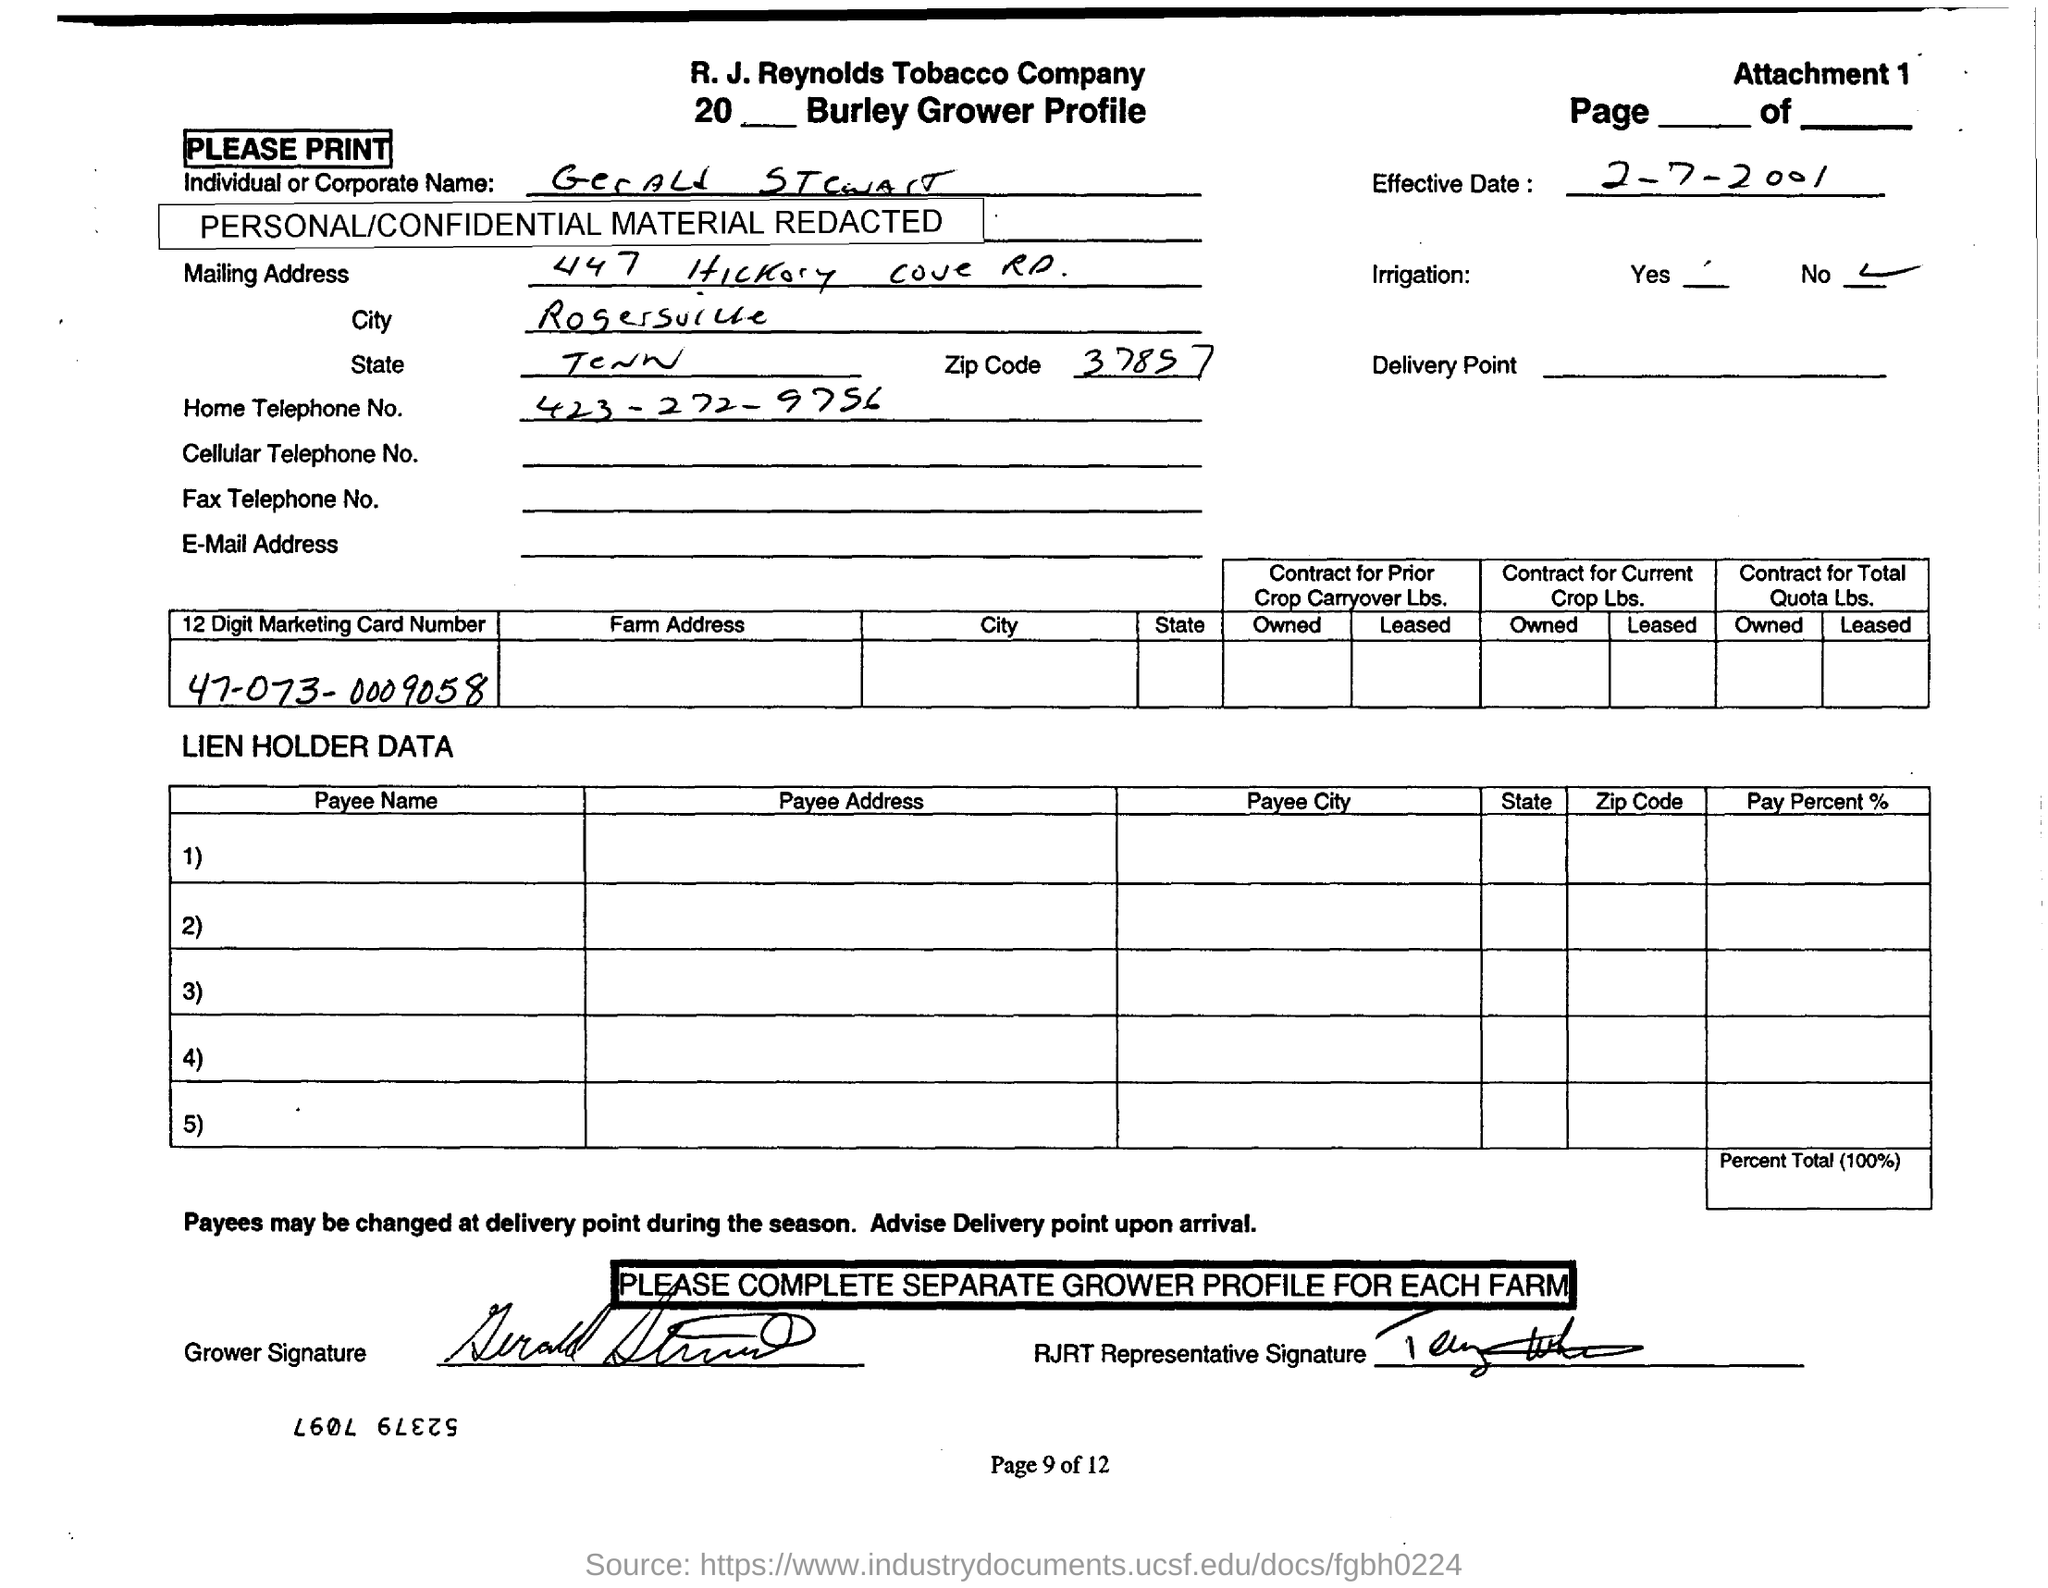Point out several critical features in this image. The mailing address mentioned includes a ZIP code of 37857. The R. J. Reynolds Tobacco Company is mentioned in the header. The provision of irrigation is not made. The 12-digit marketing card number written in the first table is 470730009058... The Effective Date mentioned in the text is 2-7-2001. 